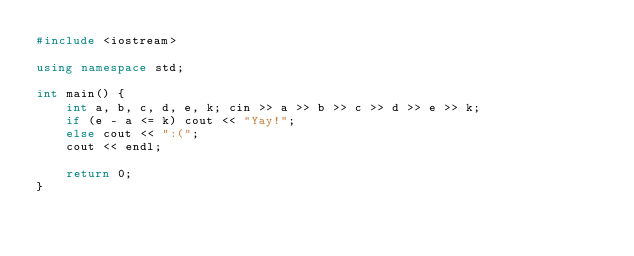<code> <loc_0><loc_0><loc_500><loc_500><_C++_>#include <iostream>

using namespace std;

int main() {
	int a, b, c, d, e, k; cin >> a >> b >> c >> d >> e >> k;
	if (e - a <= k) cout << "Yay!";
	else cout << ":(";
	cout << endl;

	return 0;
}</code> 